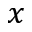<formula> <loc_0><loc_0><loc_500><loc_500>x</formula> 